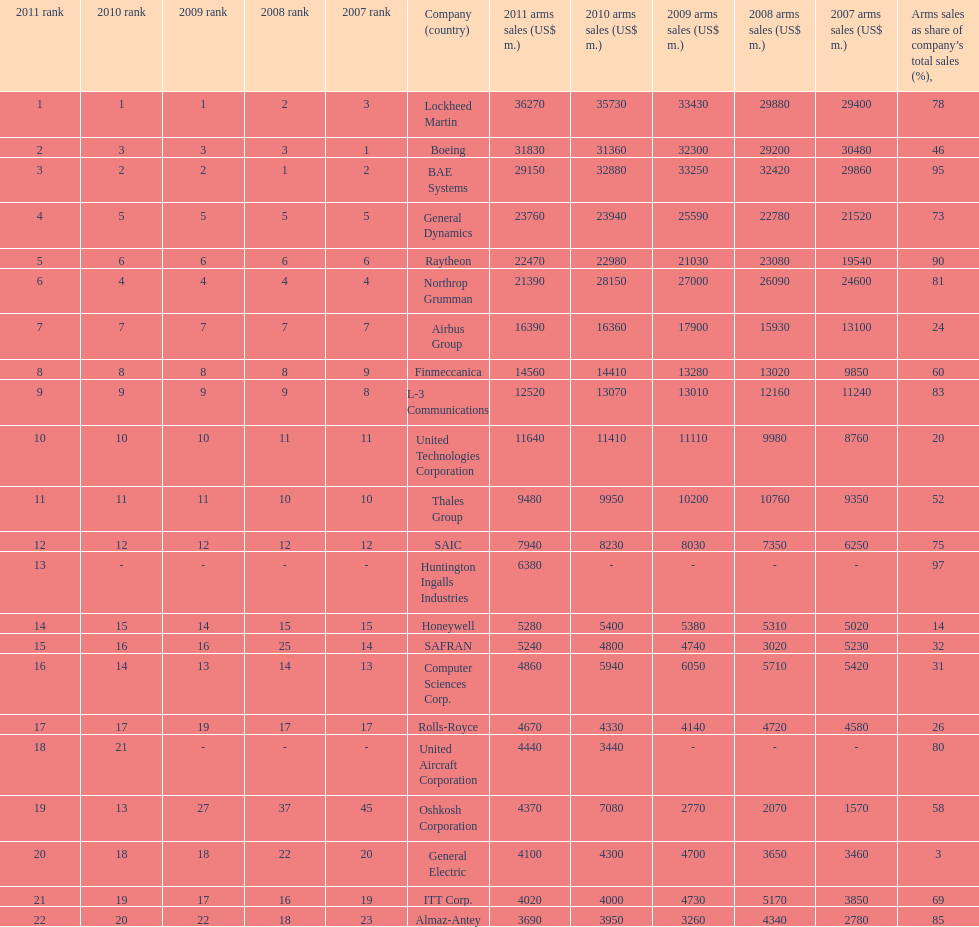How many different countries are listed? 6. 